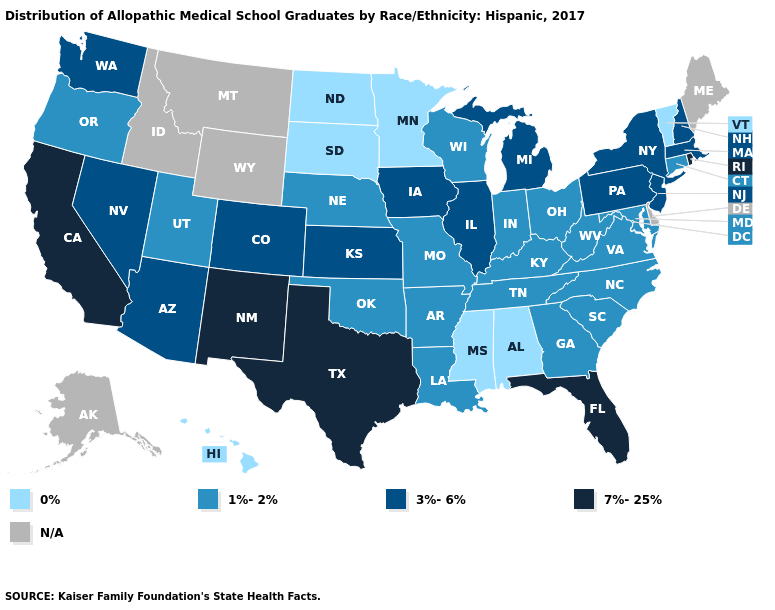What is the lowest value in states that border Maine?
Answer briefly. 3%-6%. Does Vermont have the lowest value in the USA?
Quick response, please. Yes. Name the states that have a value in the range 0%?
Write a very short answer. Alabama, Hawaii, Minnesota, Mississippi, North Dakota, South Dakota, Vermont. Does the map have missing data?
Concise answer only. Yes. Is the legend a continuous bar?
Keep it brief. No. What is the value of California?
Answer briefly. 7%-25%. What is the highest value in the Northeast ?
Be succinct. 7%-25%. Which states hav the highest value in the West?
Answer briefly. California, New Mexico. Which states have the highest value in the USA?
Keep it brief. California, Florida, New Mexico, Rhode Island, Texas. Name the states that have a value in the range 3%-6%?
Answer briefly. Arizona, Colorado, Illinois, Iowa, Kansas, Massachusetts, Michigan, Nevada, New Hampshire, New Jersey, New York, Pennsylvania, Washington. Which states have the highest value in the USA?
Concise answer only. California, Florida, New Mexico, Rhode Island, Texas. Does Kentucky have the highest value in the South?
Be succinct. No. Name the states that have a value in the range 7%-25%?
Give a very brief answer. California, Florida, New Mexico, Rhode Island, Texas. What is the highest value in the USA?
Answer briefly. 7%-25%. 